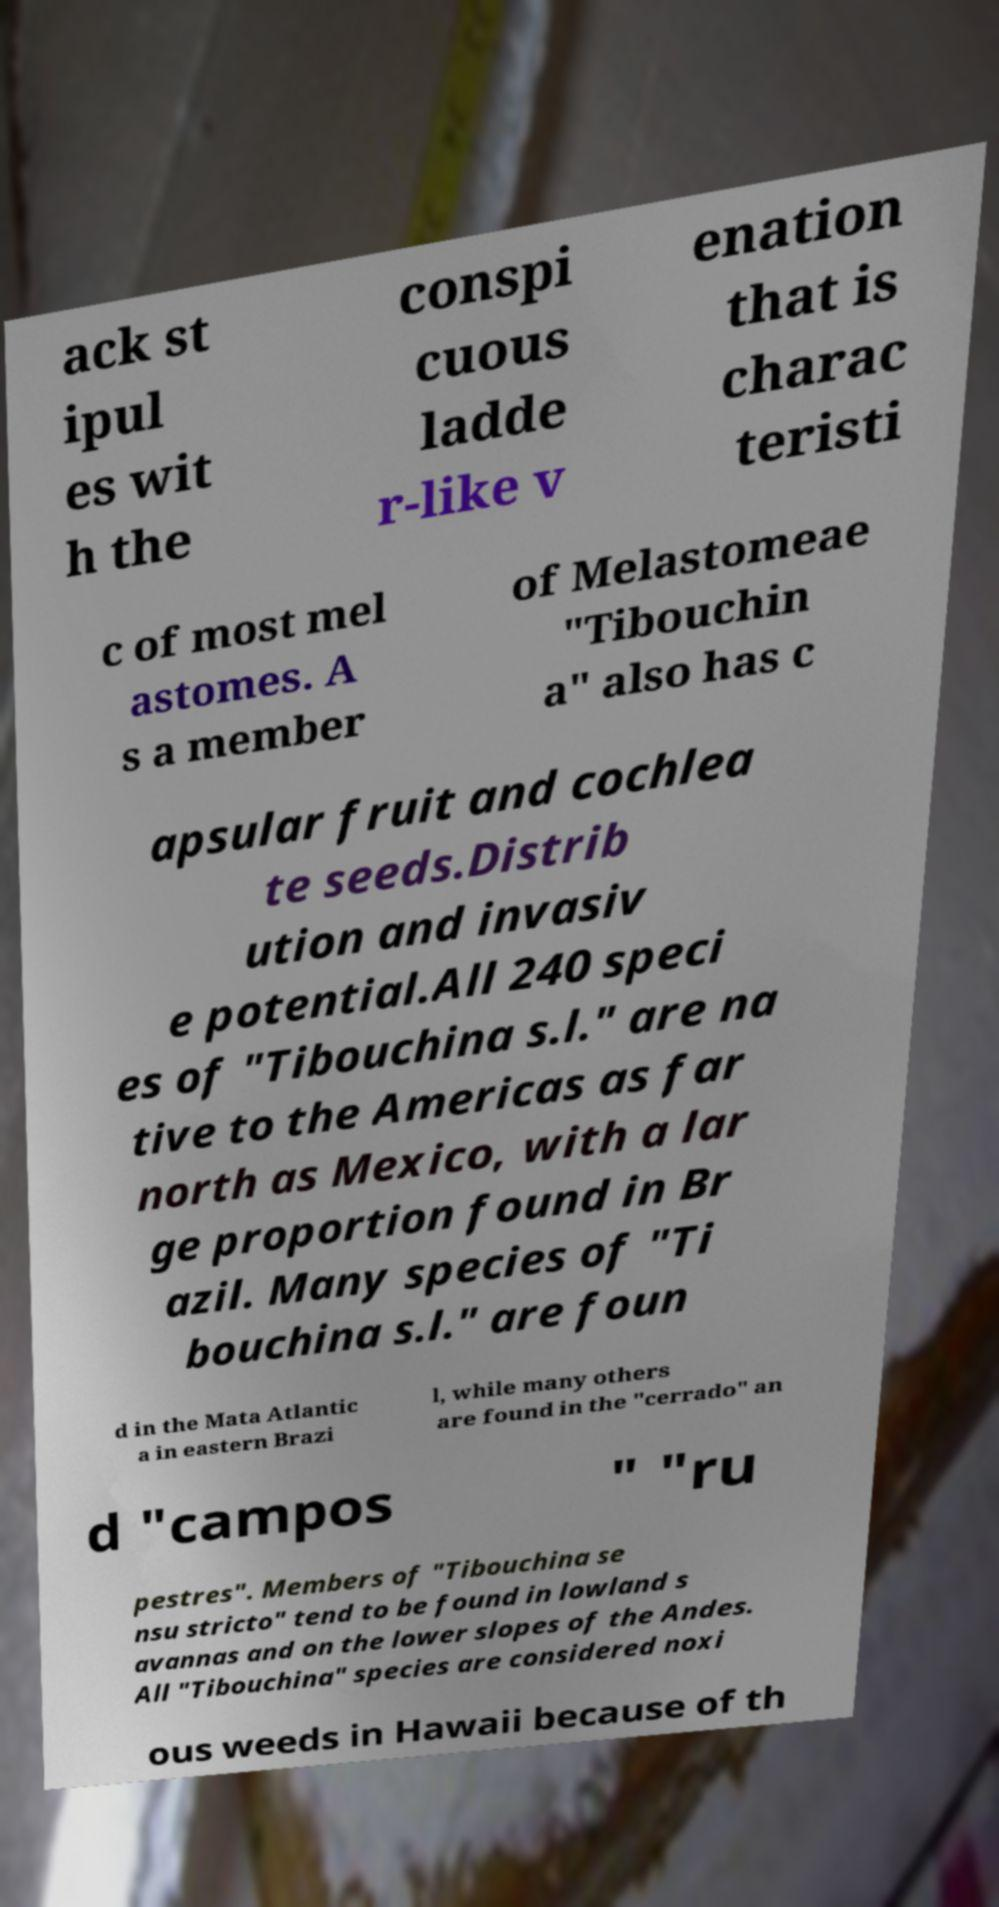What messages or text are displayed in this image? I need them in a readable, typed format. ack st ipul es wit h the conspi cuous ladde r-like v enation that is charac teristi c of most mel astomes. A s a member of Melastomeae "Tibouchin a" also has c apsular fruit and cochlea te seeds.Distrib ution and invasiv e potential.All 240 speci es of "Tibouchina s.l." are na tive to the Americas as far north as Mexico, with a lar ge proportion found in Br azil. Many species of "Ti bouchina s.l." are foun d in the Mata Atlantic a in eastern Brazi l, while many others are found in the "cerrado" an d "campos " "ru pestres". Members of "Tibouchina se nsu stricto" tend to be found in lowland s avannas and on the lower slopes of the Andes. All "Tibouchina" species are considered noxi ous weeds in Hawaii because of th 